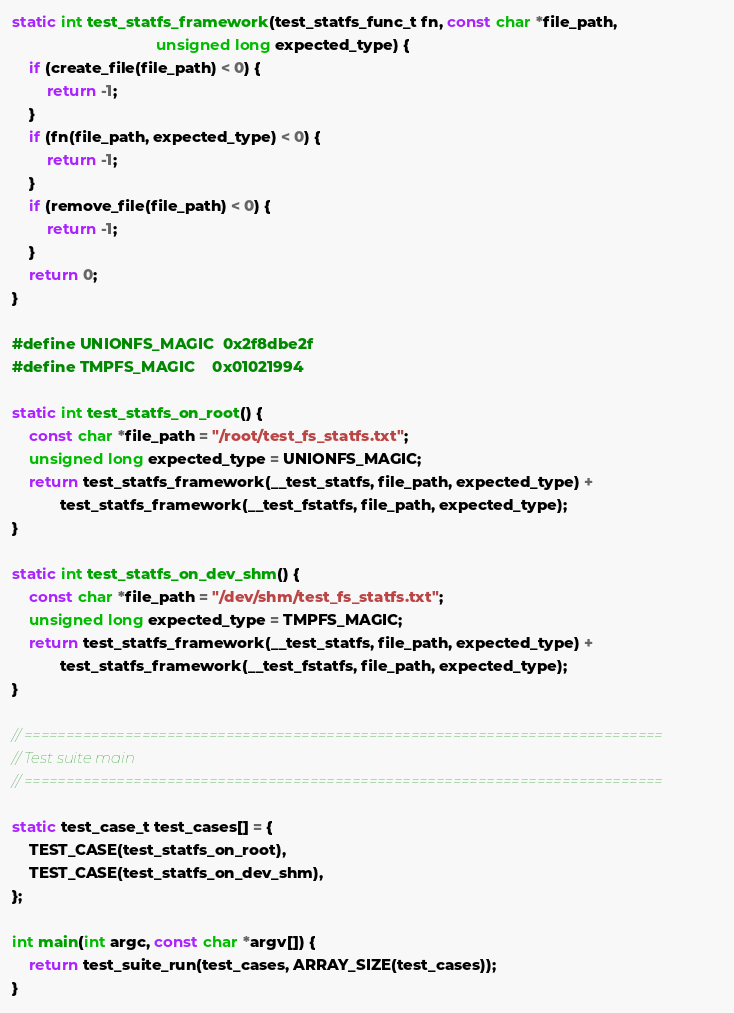Convert code to text. <code><loc_0><loc_0><loc_500><loc_500><_C_>static int test_statfs_framework(test_statfs_func_t fn, const char *file_path,
                                 unsigned long expected_type) {
    if (create_file(file_path) < 0) {
        return -1;
    }
    if (fn(file_path, expected_type) < 0) {
        return -1;
    }
    if (remove_file(file_path) < 0) {
        return -1;
    }
    return 0;
}

#define UNIONFS_MAGIC  0x2f8dbe2f
#define TMPFS_MAGIC    0x01021994

static int test_statfs_on_root() {
    const char *file_path = "/root/test_fs_statfs.txt";
    unsigned long expected_type = UNIONFS_MAGIC;
    return test_statfs_framework(__test_statfs, file_path, expected_type) +
           test_statfs_framework(__test_fstatfs, file_path, expected_type);
}

static int test_statfs_on_dev_shm() {
    const char *file_path = "/dev/shm/test_fs_statfs.txt";
    unsigned long expected_type = TMPFS_MAGIC;
    return test_statfs_framework(__test_statfs, file_path, expected_type) +
           test_statfs_framework(__test_fstatfs, file_path, expected_type);
}

// ============================================================================
// Test suite main
// ============================================================================

static test_case_t test_cases[] = {
    TEST_CASE(test_statfs_on_root),
    TEST_CASE(test_statfs_on_dev_shm),
};

int main(int argc, const char *argv[]) {
    return test_suite_run(test_cases, ARRAY_SIZE(test_cases));
}
</code> 